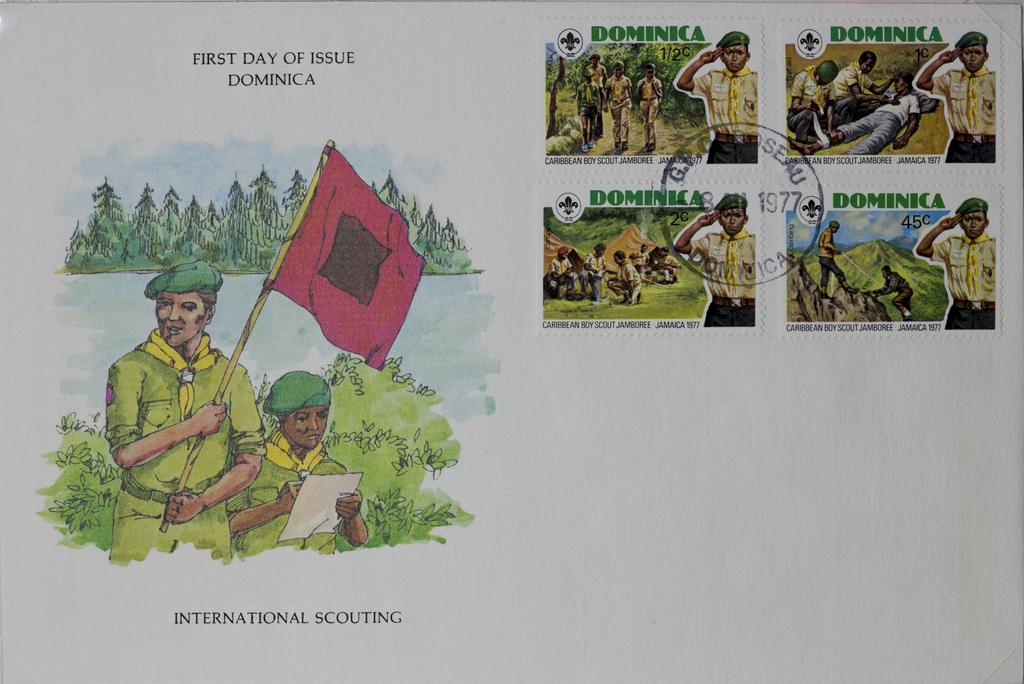<image>
Create a compact narrative representing the image presented. Illustrated postcard postmarked from 1977 showing military men. 